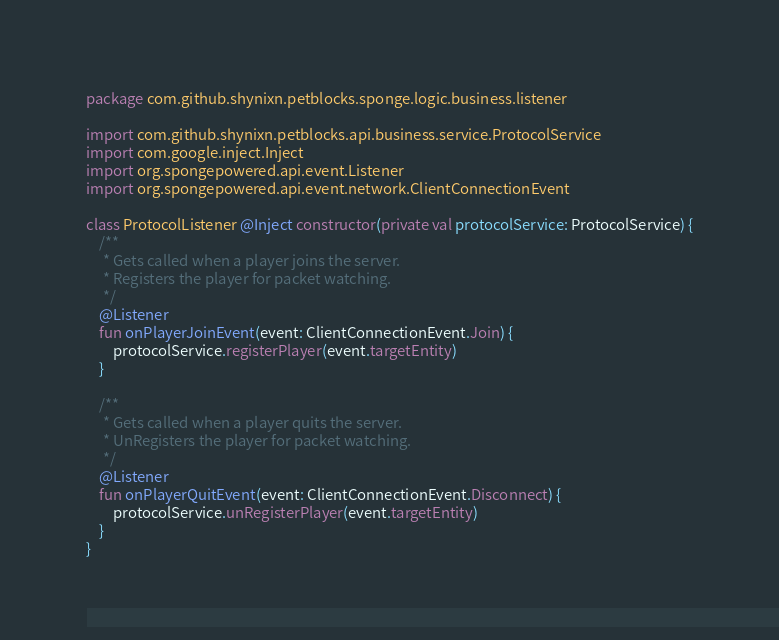Convert code to text. <code><loc_0><loc_0><loc_500><loc_500><_Kotlin_>package com.github.shynixn.petblocks.sponge.logic.business.listener

import com.github.shynixn.petblocks.api.business.service.ProtocolService
import com.google.inject.Inject
import org.spongepowered.api.event.Listener
import org.spongepowered.api.event.network.ClientConnectionEvent

class ProtocolListener @Inject constructor(private val protocolService: ProtocolService) {
    /**
     * Gets called when a player joins the server.
     * Registers the player for packet watching.
     */
    @Listener
    fun onPlayerJoinEvent(event: ClientConnectionEvent.Join) {
        protocolService.registerPlayer(event.targetEntity)
    }

    /**
     * Gets called when a player quits the server.
     * UnRegisters the player for packet watching.
     */
    @Listener
    fun onPlayerQuitEvent(event: ClientConnectionEvent.Disconnect) {
        protocolService.unRegisterPlayer(event.targetEntity)
    }
}
</code> 